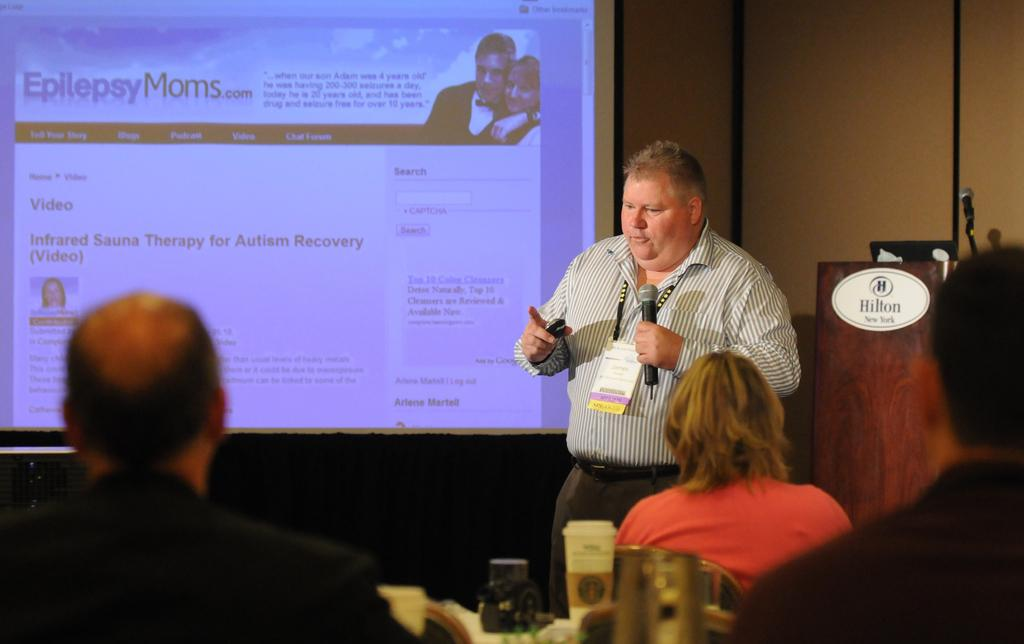What is the person in the image holding? The person in the image is holding a microphone. What can be seen behind the person? There is a screen in the image. How many people are visible in the image? There are people in the image. What is the person standing behind? There is a podium in the image. Can you describe any other objects in the image? There are other unspecified objects in the image. Is there a bat involved in a fight during the rainstorm depicted in the image? There is no bat, fight, or rainstorm depicted in the image; it features a person holding a microphone, a screen, people, a podium, and unspecified objects. 